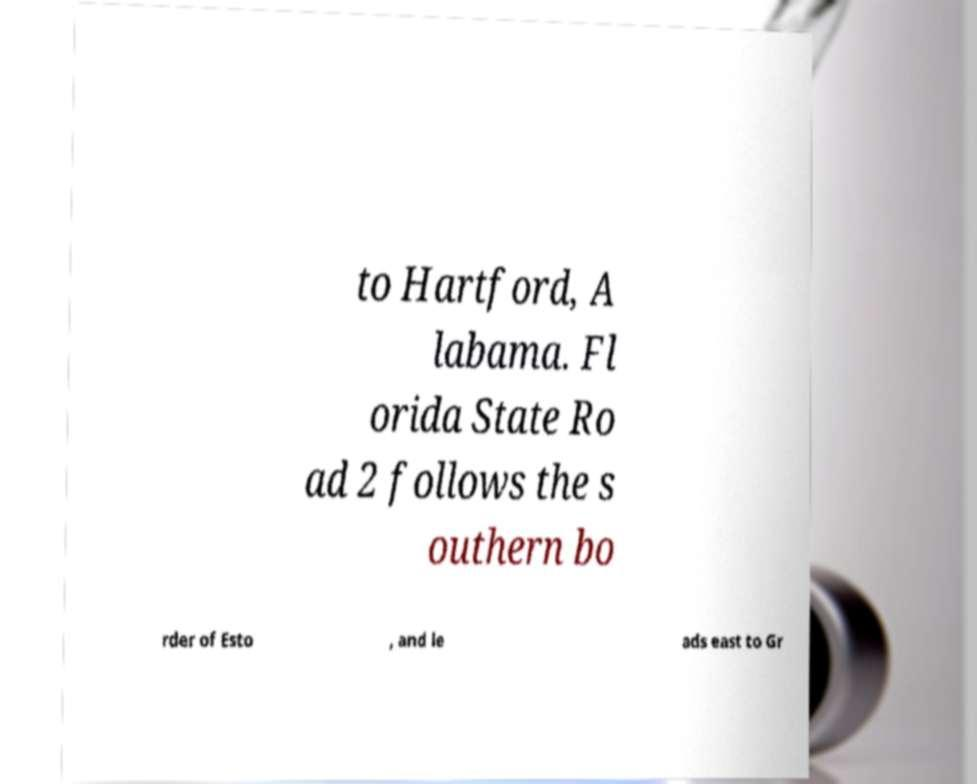I need the written content from this picture converted into text. Can you do that? to Hartford, A labama. Fl orida State Ro ad 2 follows the s outhern bo rder of Esto , and le ads east to Gr 